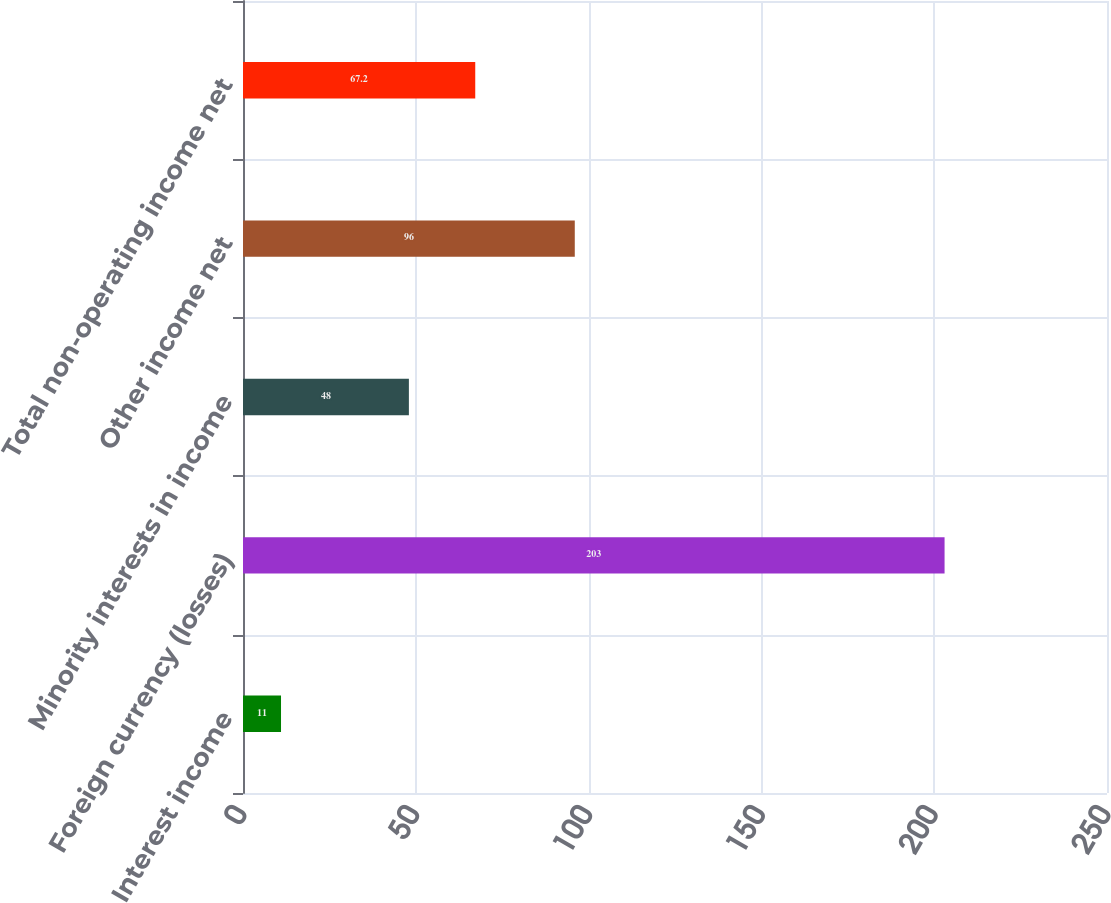Convert chart. <chart><loc_0><loc_0><loc_500><loc_500><bar_chart><fcel>Interest income<fcel>Foreign currency (losses)<fcel>Minority interests in income<fcel>Other income net<fcel>Total non-operating income net<nl><fcel>11<fcel>203<fcel>48<fcel>96<fcel>67.2<nl></chart> 